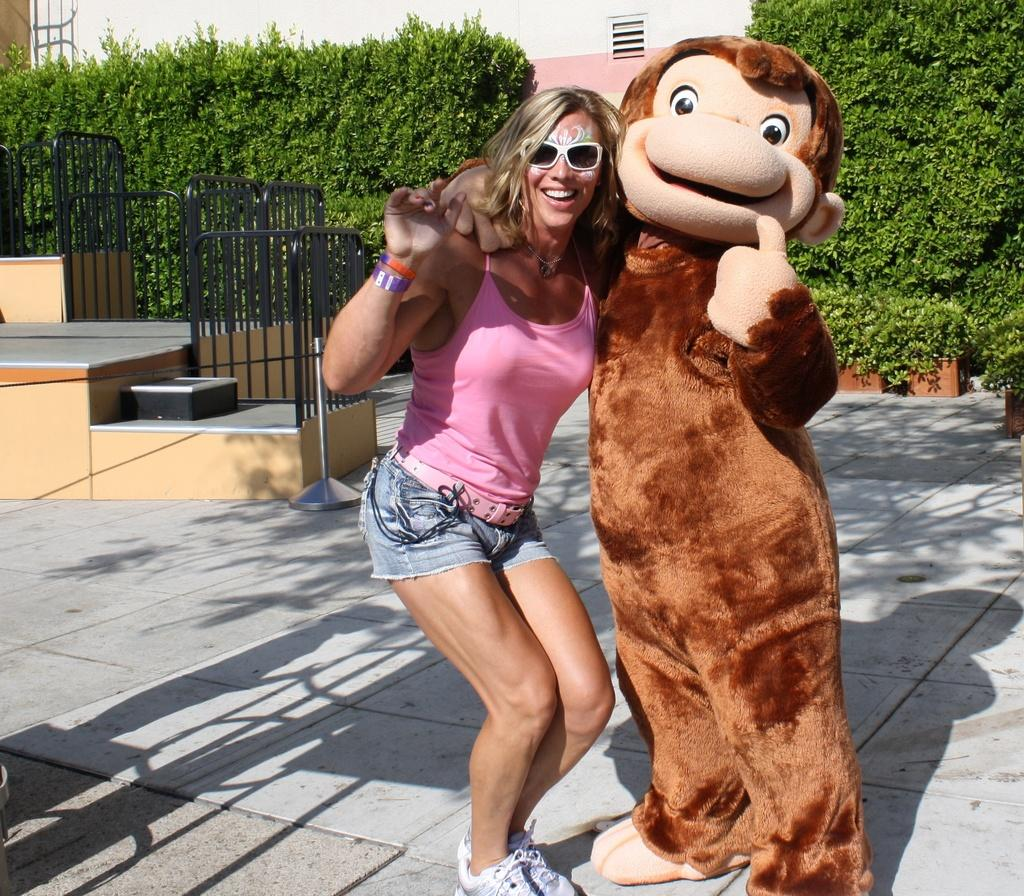What is present in the image along with the person? There is a mascot in the image. What can be seen in the image that might provide support or safety? There are railings in the image. What type of natural elements are visible in the image? There are trees in the image. What can be seen in the background of the image? There is a building in the background of the image. What type of song is the band playing in the image? There is no band present in the image, so it is not possible to determine what song might be played. 